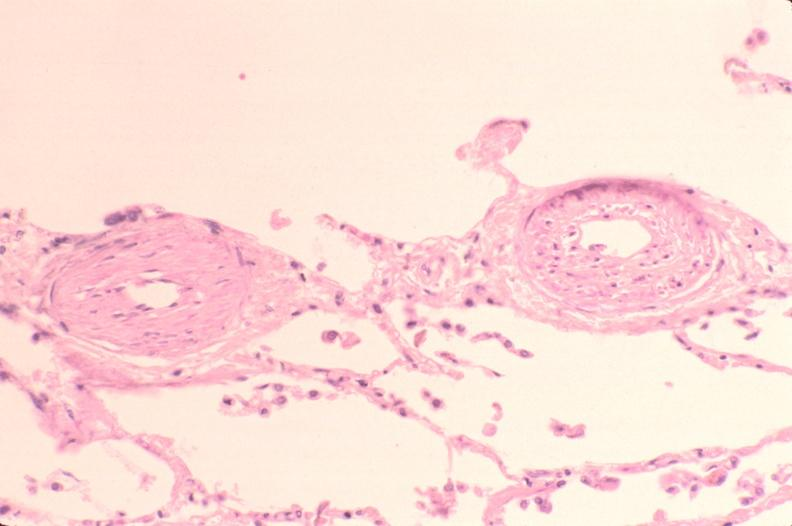s respiratory present?
Answer the question using a single word or phrase. Yes 